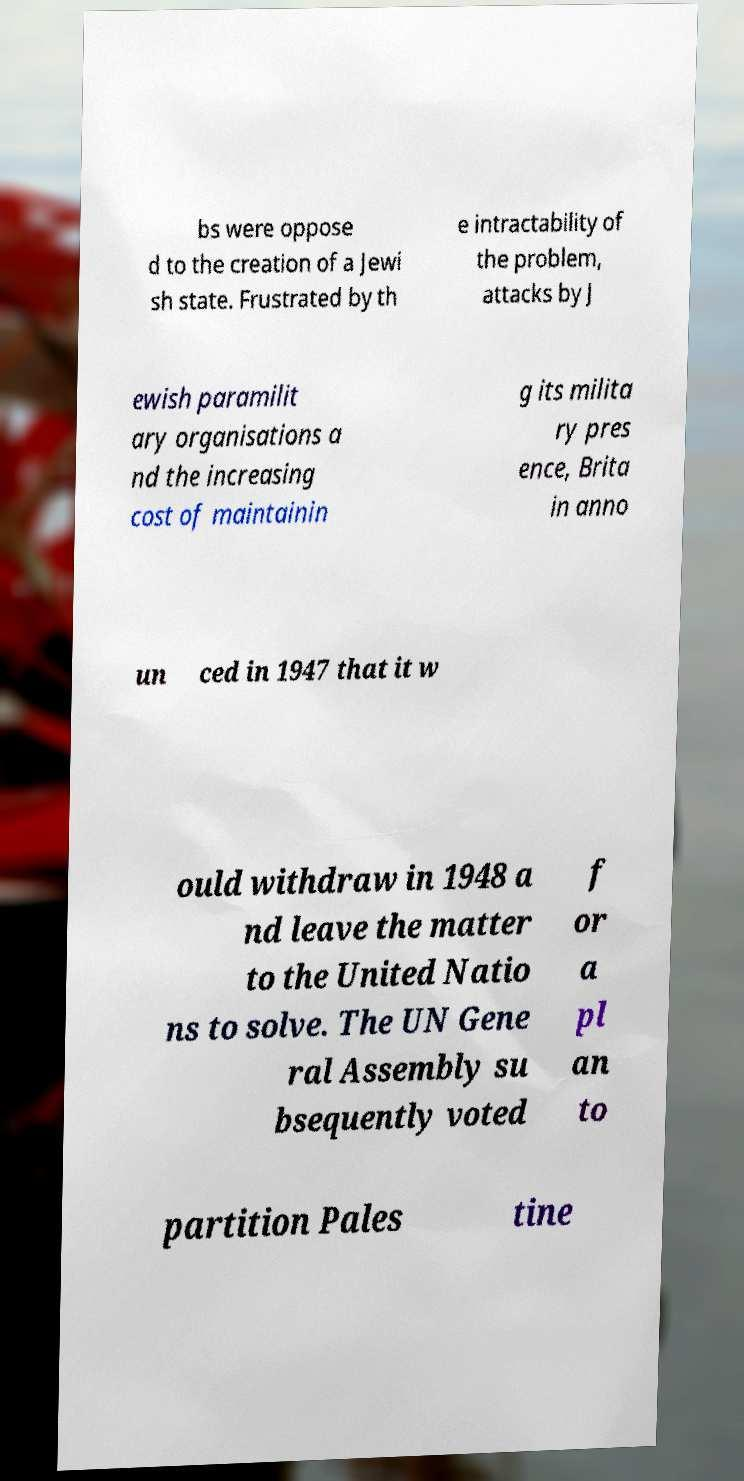Please read and relay the text visible in this image. What does it say? bs were oppose d to the creation of a Jewi sh state. Frustrated by th e intractability of the problem, attacks by J ewish paramilit ary organisations a nd the increasing cost of maintainin g its milita ry pres ence, Brita in anno un ced in 1947 that it w ould withdraw in 1948 a nd leave the matter to the United Natio ns to solve. The UN Gene ral Assembly su bsequently voted f or a pl an to partition Pales tine 